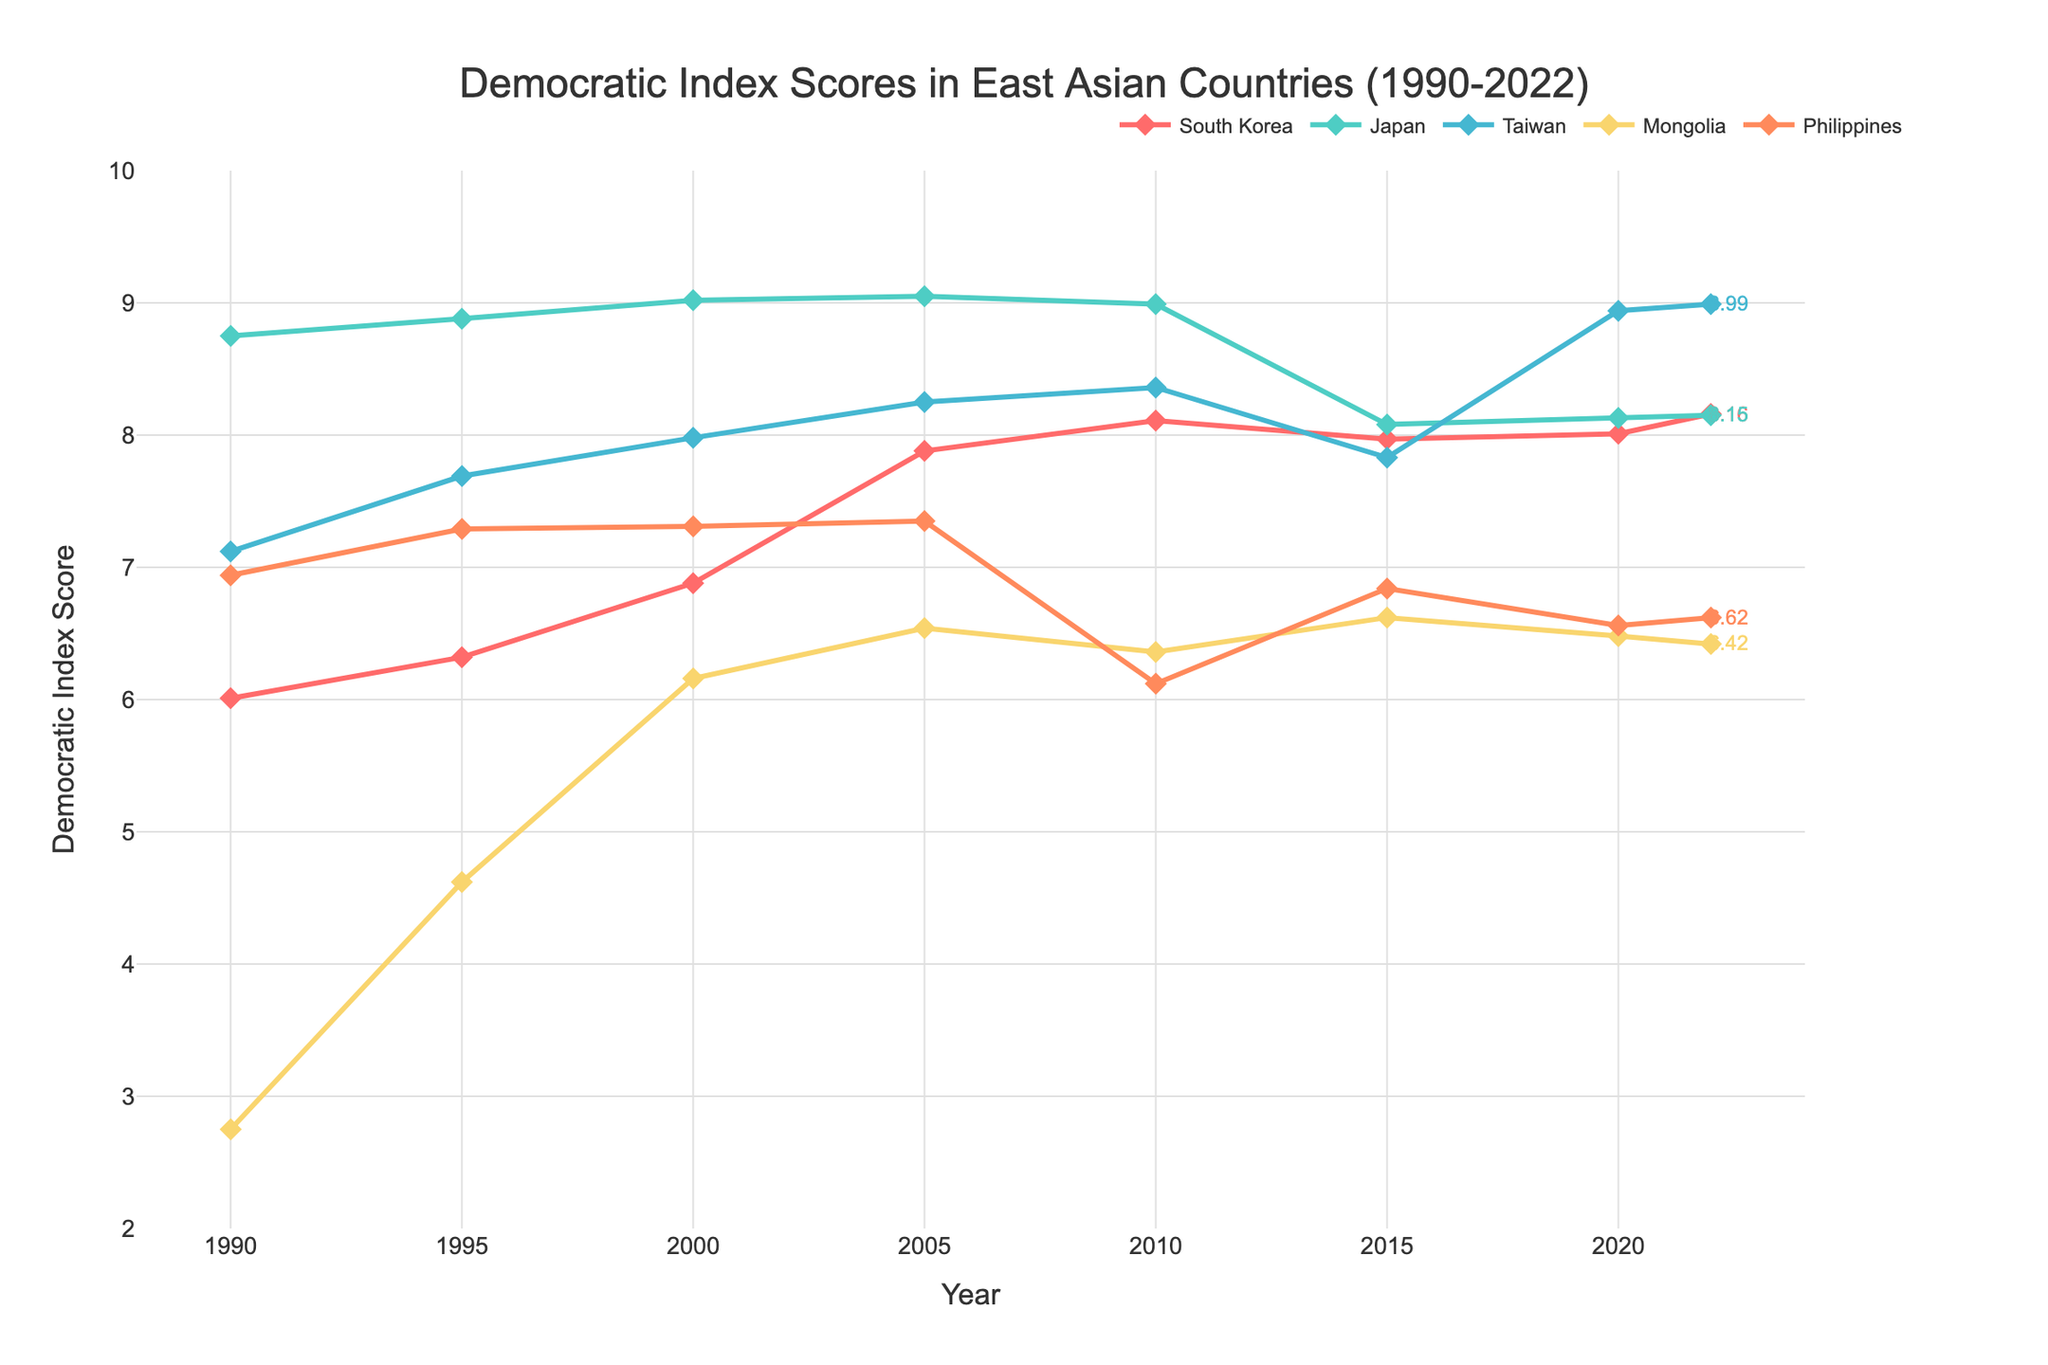What is the Democratic Index Score of South Korea in 2022? Refer to the chart and locate the point for South Korea in 2022. The Democratic Index Score of South Korea is indicated near that point and is also annotated directly on the plot.
Answer: 8.16 Which country had the highest Democratic Index Score in 2022? Look for the country with the highest annotated score in 2022. All annotated values are present at the end of each country's line.
Answer: Taiwan What is the difference in Democratic Index Score between South Korea and the Philippines in 2022? Find the annotated scores for both South Korea and the Philippines in 2022. Subtract the Philippines' score from South Korea's score: 8.16 - 6.62.
Answer: 1.54 Which country had the largest increase in Democratic Index Score between 1990 and 2022? Compare the values for each country in 1990 and 2022. Calculate the increase for each: South Korea (8.16 - 6.01 = 2.15), Japan (8.15 - 8.75 = -0.60), Taiwan (8.99 - 7.12 = 1.87), Mongolia (6.42 - 2.75 = 3.67), Philippines (6.62 - 6.94 = -0.32).
Answer: Mongolia How does the trend of Democratic Index Scores for Japan compare to South Korea from 1990 to 2022? Observe the lines corresponding to Japan and South Korea. Japan starts higher than South Korea and slightly decreases, while South Korea generally shows an increasing trend. This suggests a narrowing gap between the two countries over time.
Answer: Japan decreased slightly, South Korea increased In what year did South Korea's Democratic Index Score surpass 8 for the first time? Look at the Democratic Index Score for South Korea and identify the year when it first goes above 8. This happens between 2005 and 2010.
Answer: 2010 By how much did Mongolia's Democratic Index Score increase from 1990 to 2000? Find Mongolia's scores in 1990 and 2000. Subtract 1990's score from 2000's score: 6.16 - 2.75.
Answer: 3.41 In which year did Taiwan's Democratic Index Score surpass Japan's for the first time? Compare Taiwan's and Japan's scores year by year and find the first year Taiwan's score exceeds Japan's score. Notice that this happens between 2015 and 2020. Confirm by checking 2020.
Answer: 2020 What is the average Democratic Index Score of South Korea from 1990 to 2022? Compute the average by adding South Korea's scores from each year and then dividing by the number of years. (6.01 + 6.32 + 6.88 + 7.88 + 8.11 + 7.97 + 8.01 + 8.16) / 8.
Answer: 7.42 Which country experienced the most fluctuation in Democratic Index Score from 1990 to 2022? Examine the trend lines for all countries and identify which line has the most variation (ups and downs). The Philippines shows notable fluctuations compared to steadier lines of other countries.
Answer: Philippines 